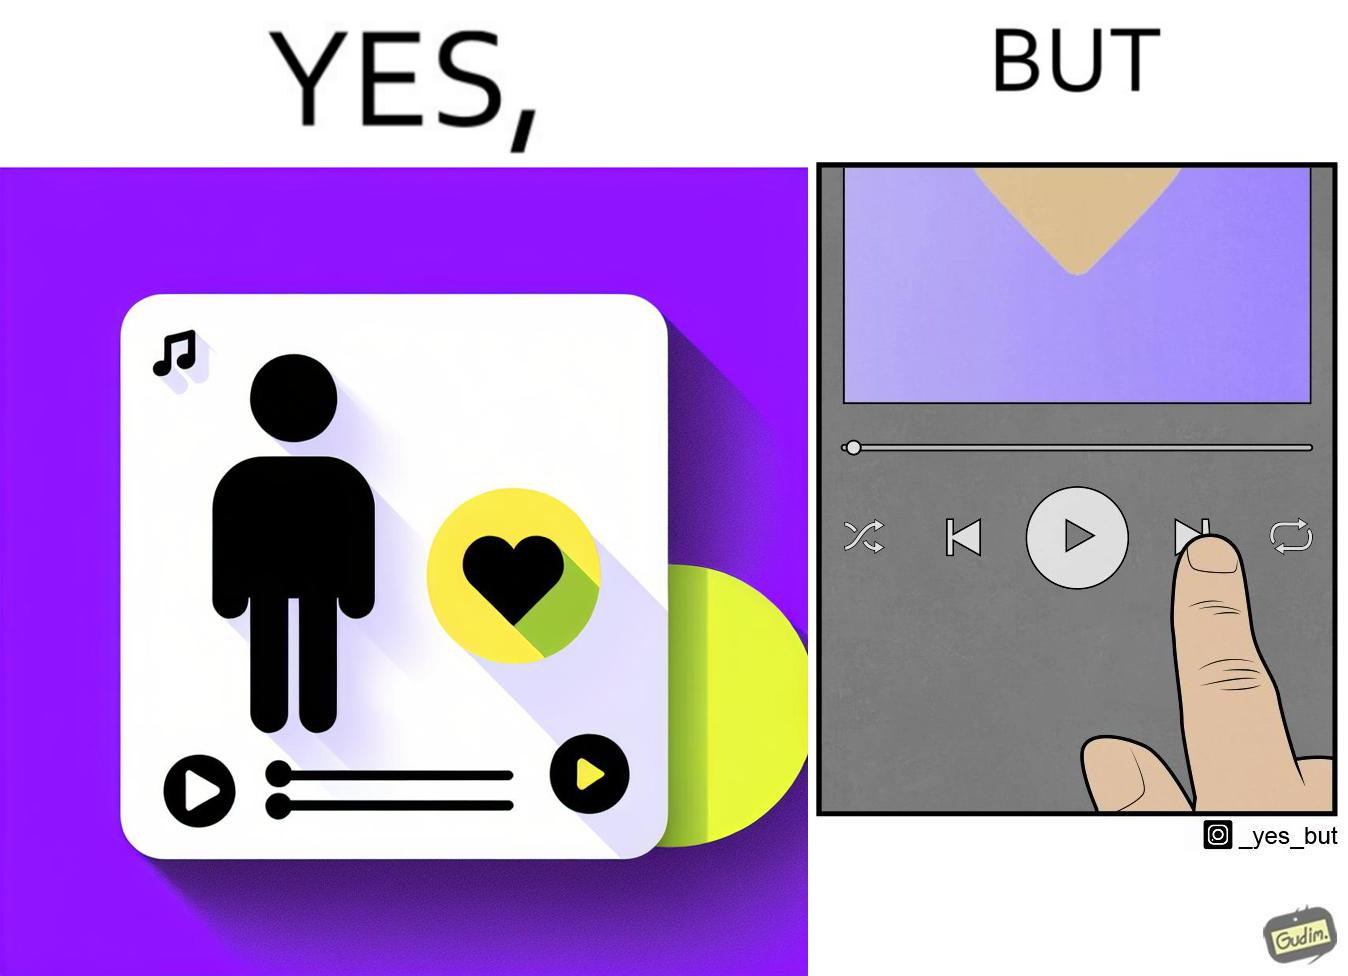Provide a description of this image. The image is funny because while the playlist is labelled "music I love" indicating that all the music in the playlist is very well liked by the user but the user is pressing play next button after listening to a few seconds of one of the audios in the playlist. 